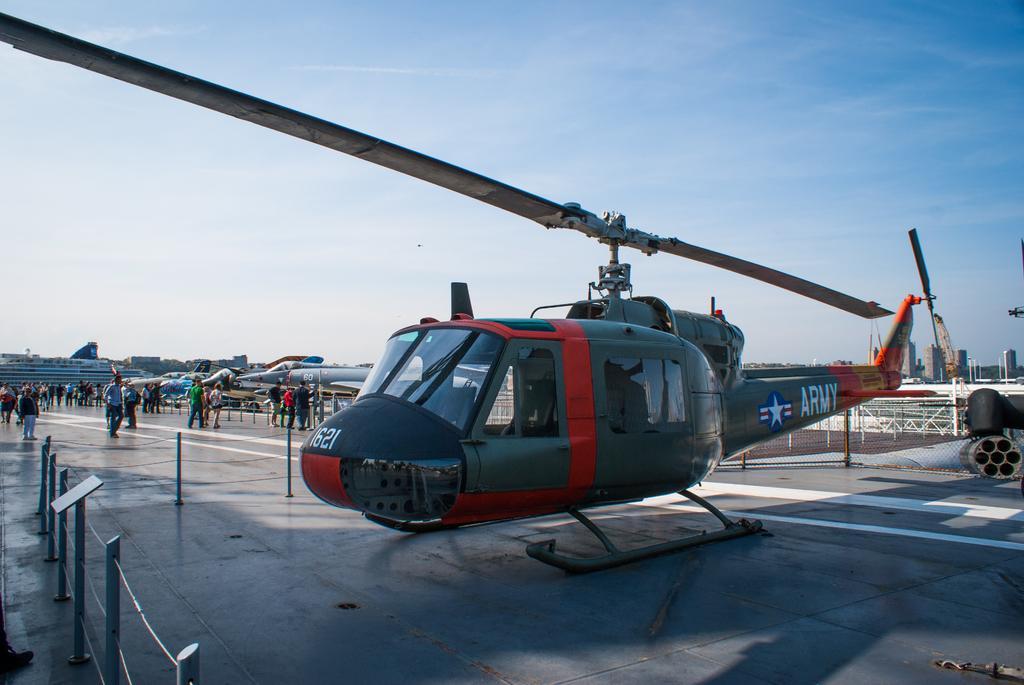Can you describe this image briefly? In this picture we can see a helicopter, airplanes, people on the ground, here we can see a fence and some objects and in the background we can see buildings, sky. 